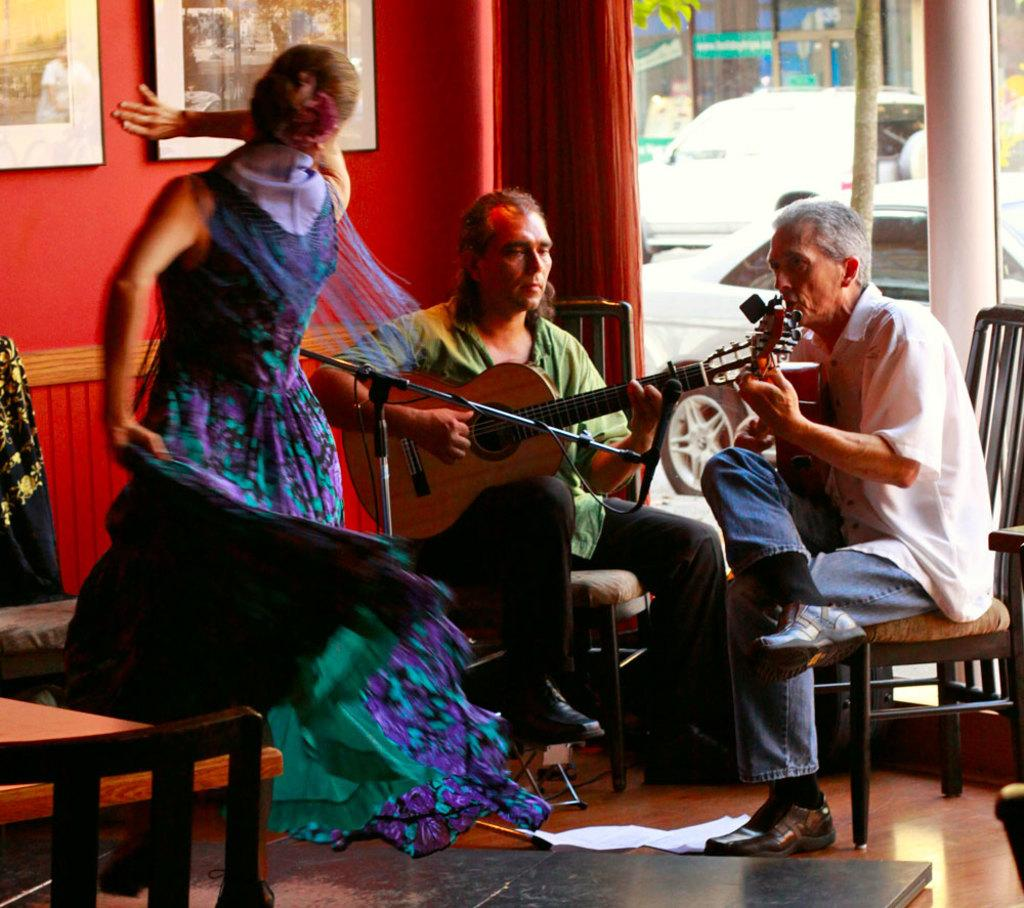How many people are visible in the image? There are 2 people sitting in the image. What are the people doing? The people are playing guitar. Is there any other activity happening in the image? Yes, there is a person dancing in front of the guitar players. What can be seen in the background of the image? There is a red wall in the background. Are there any decorations on the red wall? Yes, there are photo frames on the red wall. Reasoning: Let's think step by step by step in order to produce the conversation. We start by identifying the main subjects in the image, which are the two people playing guitar. Then, we expand the conversation to include the dancing person and the background elements, such as the red wall and photo frames. Each question is designed to elicit a specific detail about the image that is known from the provided facts. Absurd Question/Answer: What type of weather can be seen in the image? There is no indication of weather in the image, as it is an indoor scene with no visible windows or outdoor elements. 